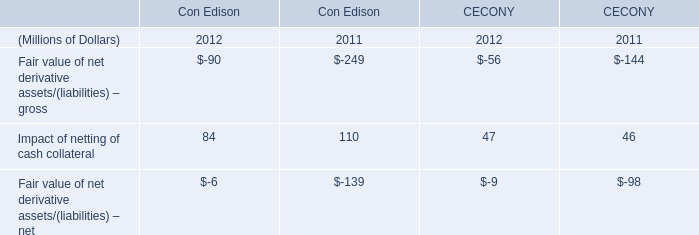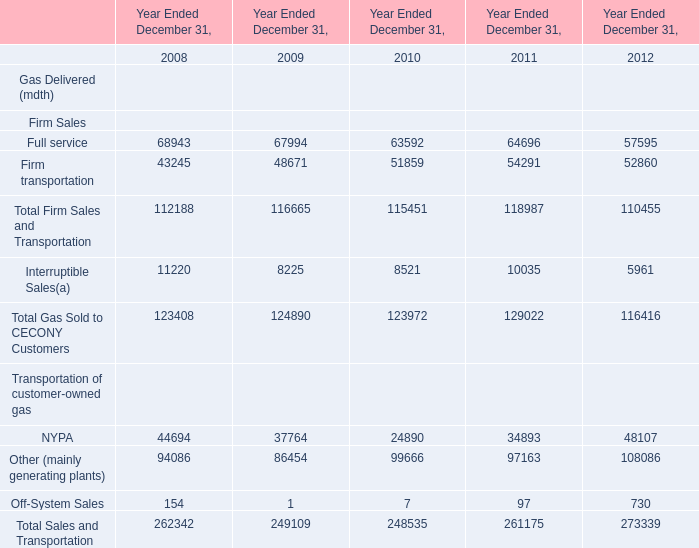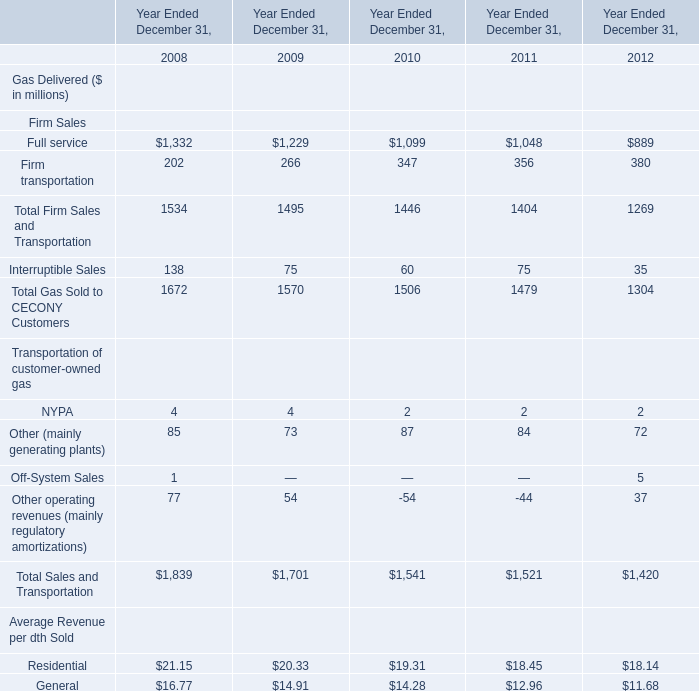What is the sum of the Full service and Firm transportation in the years where Total Gas Sold to CECONY Customers is positive? (in million) 
Computations: (1332 + 202)
Answer: 1534.0. 